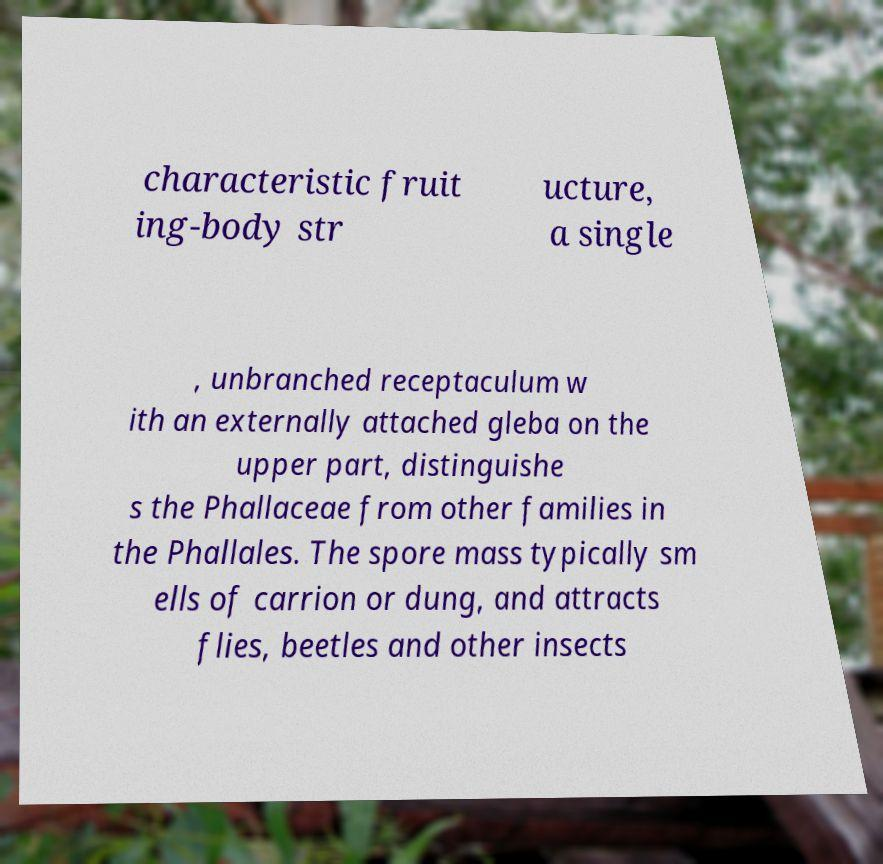Could you assist in decoding the text presented in this image and type it out clearly? characteristic fruit ing-body str ucture, a single , unbranched receptaculum w ith an externally attached gleba on the upper part, distinguishe s the Phallaceae from other families in the Phallales. The spore mass typically sm ells of carrion or dung, and attracts flies, beetles and other insects 